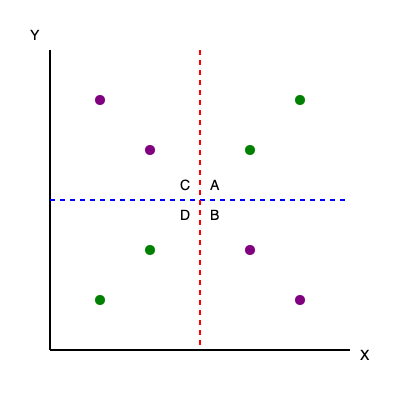Given the decision tree represented by the blue horizontal line (Y = 200) and the red vertical line (X = 200), which quadrant (A, B, C, or D) contains the highest number of misclassified data points, assuming green points belong to one class and purple points belong to another? To solve this problem, we need to follow these steps:

1. Understand the decision tree:
   - The blue horizontal line (Y = 200) and the red vertical line (X = 200) divide the plot into four quadrants: A, B, C, and D.
   - This represents a simple decision tree with two decision nodes.

2. Identify the classification rule:
   - Points above Y = 200 are classified as one class.
   - Points below Y = 200 are classified as another class.

3. Count misclassified points in each quadrant:
   - Quadrant A: 1 misclassified (1 purple point)
   - Quadrant B: 1 misclassified (1 green point)
   - Quadrant C: 1 misclassified (1 purple point)
   - Quadrant D: 1 misclassified (1 green point)

4. Compare the number of misclassified points:
   - All quadrants have the same number of misclassified points (1 each).

5. Conclusion:
   - Since all quadrants have the same number of misclassified points, there is no single quadrant with the highest number of misclassifications.
Answer: No single quadrant; all have equal misclassifications. 